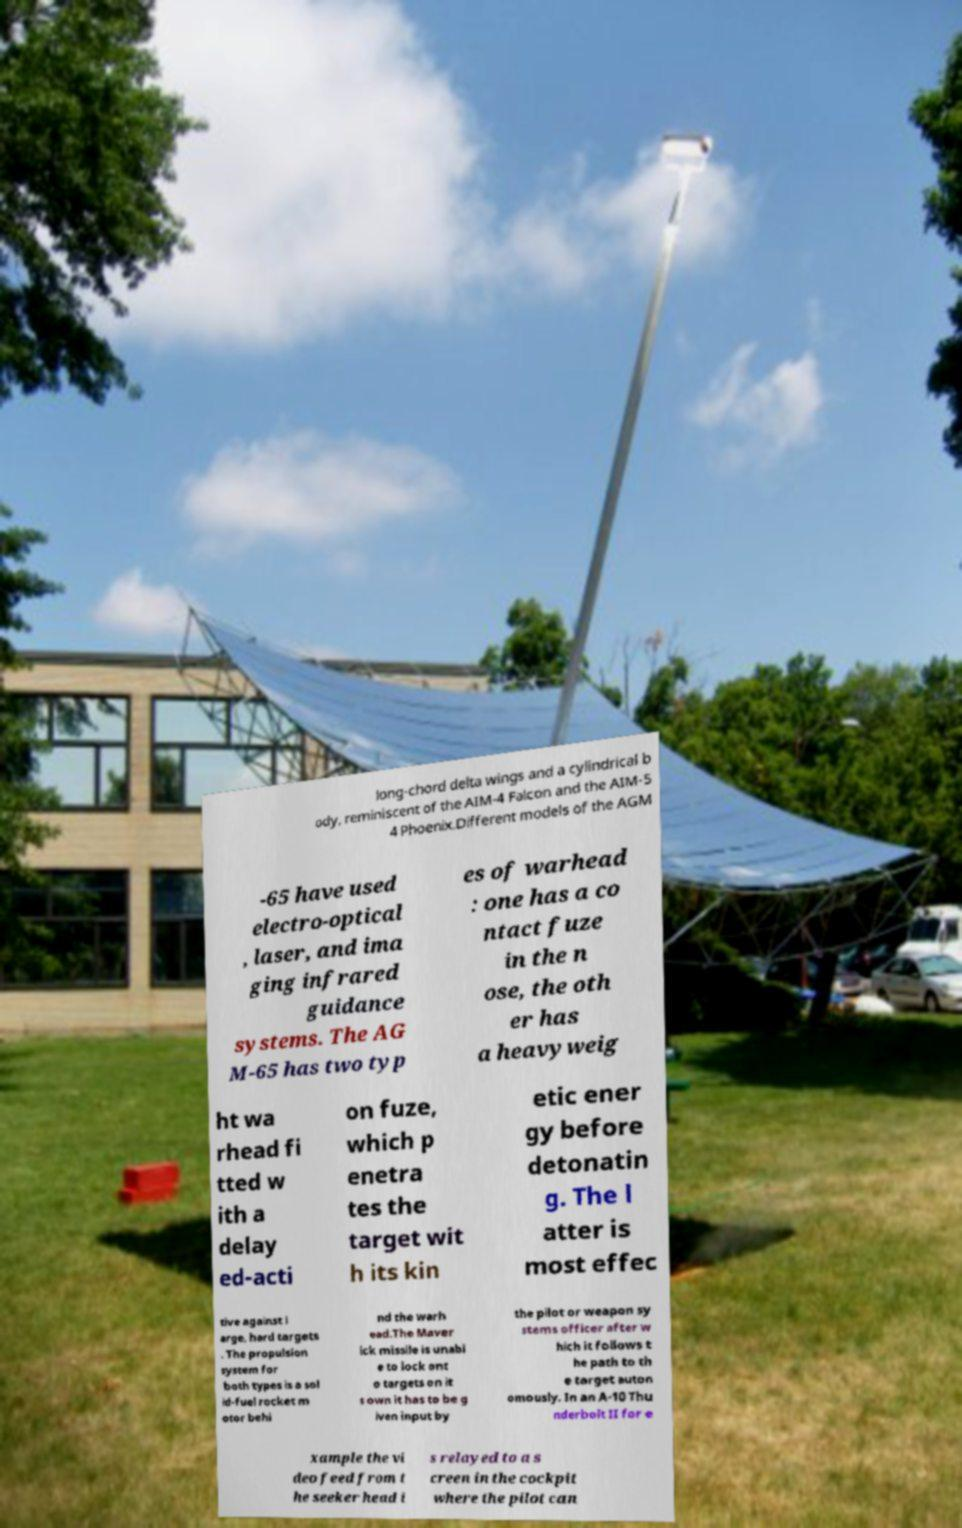Please read and relay the text visible in this image. What does it say? long-chord delta wings and a cylindrical b ody, reminiscent of the AIM-4 Falcon and the AIM-5 4 Phoenix.Different models of the AGM -65 have used electro-optical , laser, and ima ging infrared guidance systems. The AG M-65 has two typ es of warhead : one has a co ntact fuze in the n ose, the oth er has a heavyweig ht wa rhead fi tted w ith a delay ed-acti on fuze, which p enetra tes the target wit h its kin etic ener gy before detonatin g. The l atter is most effec tive against l arge, hard targets . The propulsion system for both types is a sol id-fuel rocket m otor behi nd the warh ead.The Maver ick missile is unabl e to lock ont o targets on it s own it has to be g iven input by the pilot or weapon sy stems officer after w hich it follows t he path to th e target auton omously. In an A-10 Thu nderbolt II for e xample the vi deo feed from t he seeker head i s relayed to a s creen in the cockpit where the pilot can 